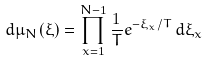Convert formula to latex. <formula><loc_0><loc_0><loc_500><loc_500>d \mu _ { N } ( \xi ) = \prod _ { x = 1 } ^ { N - 1 } \frac { 1 } { T } e ^ { - \xi _ { x } / T } \, { d \xi _ { x } }</formula> 